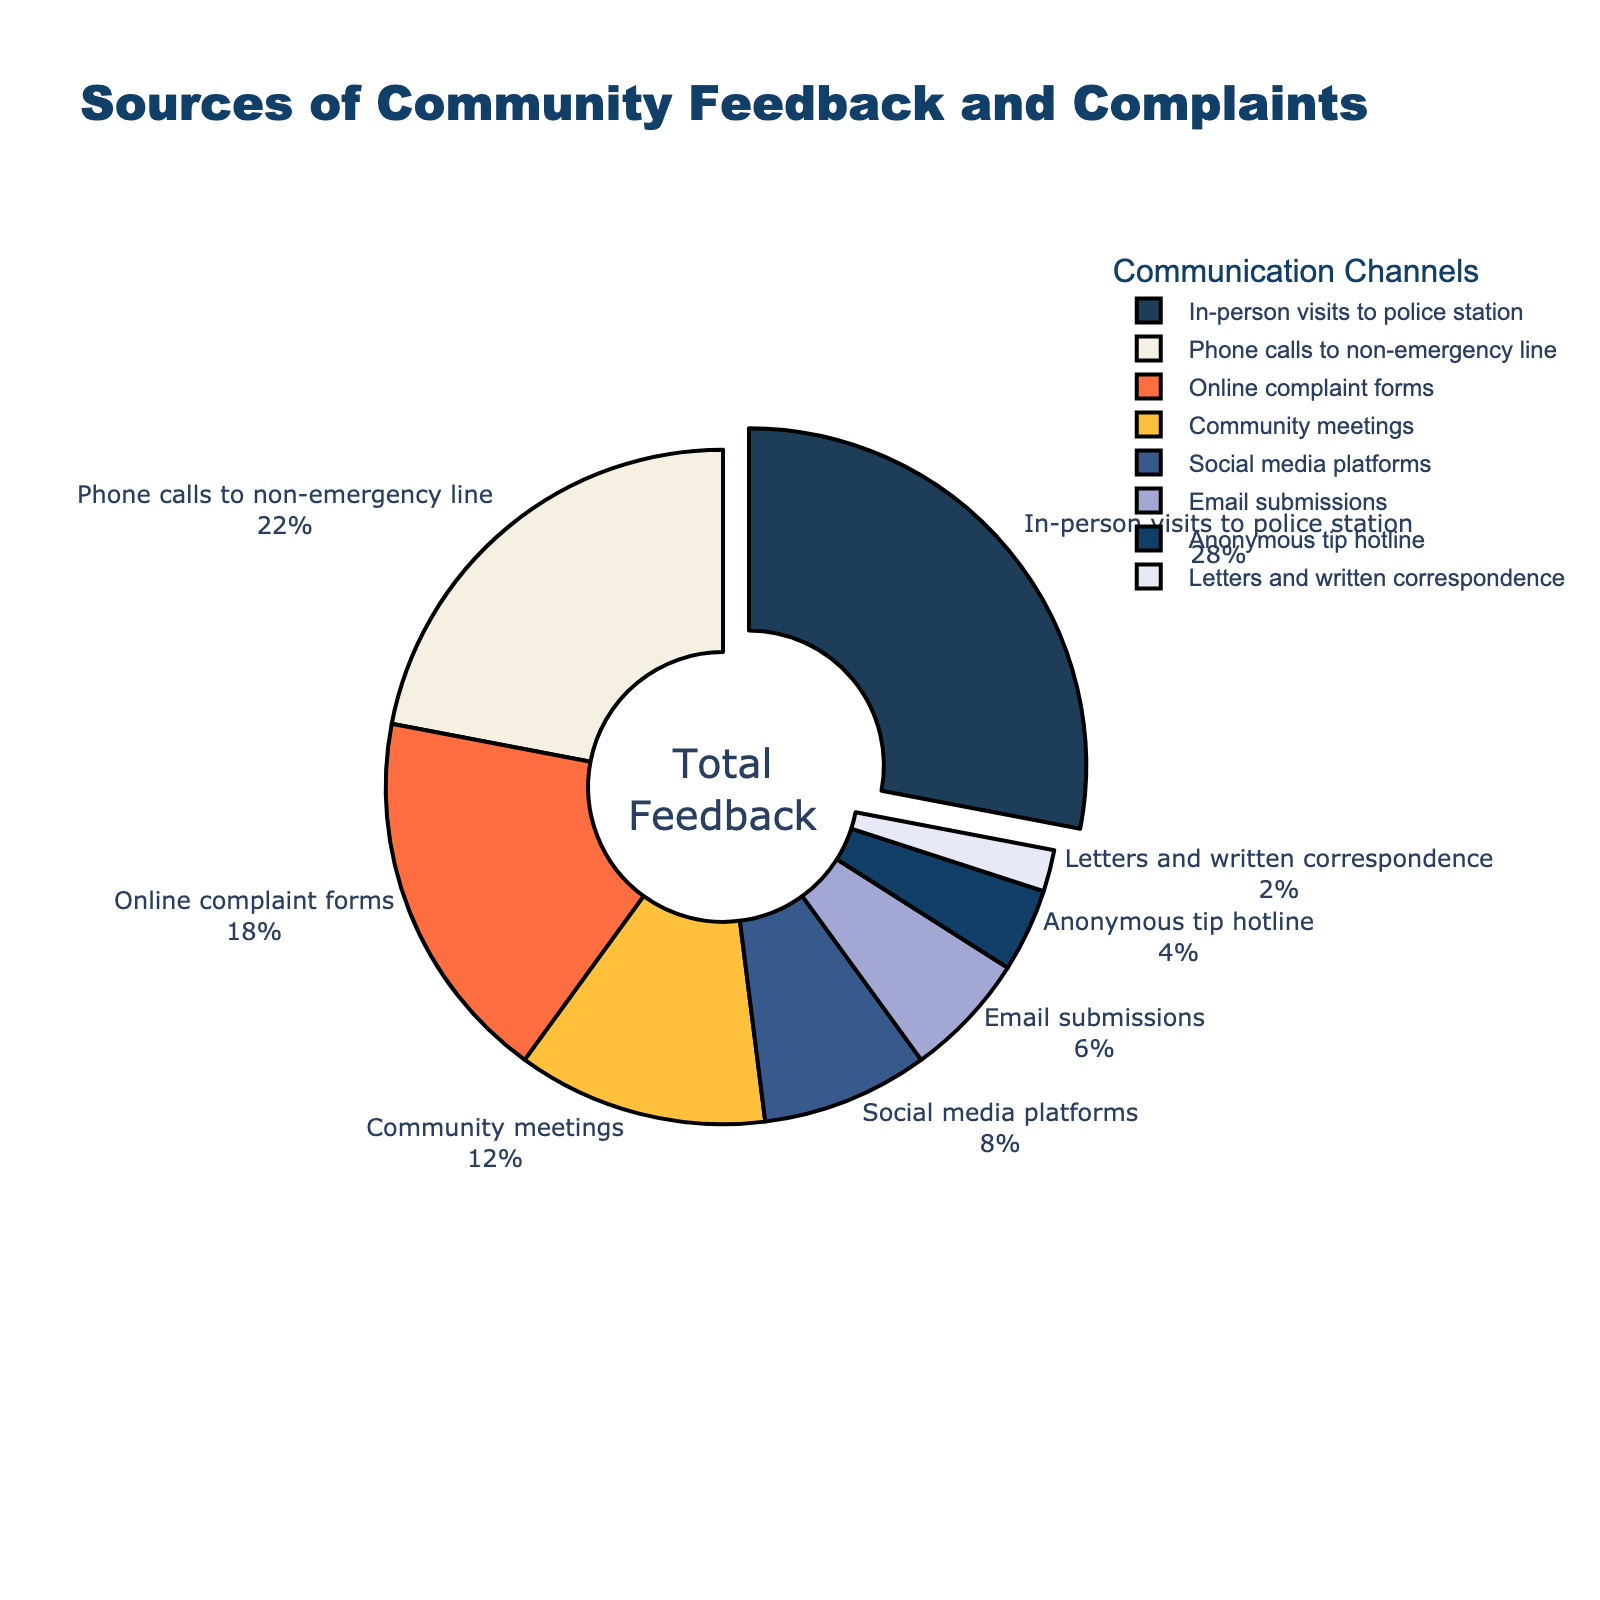In which communication channel did the police department receive the highest percentage of feedback? By observing the donut chart, the sector that is slightly pulled out indicates the communication channel with the highest percentage. This sector represents "In-person visits to police station" with 28%.
Answer: In-person visits to police station Which channels combined account for more than half of the feedback? To find this, consider the channels one by one from the highest to the lowest percentages until the combined total exceeds 50%. "In-person visits to police station" (28%) + "Phone calls to non-emergency line" (22%) = 50%, which is exactly half. Adding "Online complaint forms" (18%) exceeds half.
Answer: In-person visits to police station, Phone calls to non-emergency line, Online complaint forms What is the percentage difference between the most and least used communication channels? The most used channel is "In-person visits to police station" with 28%, and the least used is "Letters and written correspondence" with 2%. Subtract the least from the most: 28% - 2% = 26%.
Answer: 26% How much more feedback is received from "Community meetings" compared to "Social media platforms"? "Community meetings" account for 12%, while "Social media platforms" account for 8%. Subtract the smaller percentage from the larger one: 12% - 8% = 4%.
Answer: 4% Summing all the channels with less than 10% feedback, what is their total contribution? Add the percentages of channels with less than 10%: "Social media platforms" (8%) + "Email submissions" (6%) + "Anonymous tip hotline" (4%) + "Letters and written correspondence" (2%) = 8% + 6% + 4% + 2% = 20%.
Answer: 20% Which communication channels combined make up exactly 40% of the feedback? By checking different combinations that total 40%, one valid combination is "Phone calls to non-emergency line" (22%) and "Online complaint forms" (18%).
Answer: Phone calls to non-emergency line, Online complaint forms What's the average percentage of feedback received through all listed communication channels? To find the average, sum all percentages and divide by the number of channels: (28 + 22 + 18 + 12 + 8 + 6 + 4 + 2) / 8 = 100 / 8 = 12.5%.
Answer: 12.5% Which color represents the "Email submissions" section in the chart? By examining the color coding of the segments in the donut chart, the "Email submissions" section is represented by a shade of light blue-purple.
Answer: Light blue-purple ([[mention the exact color if it has a specific name]]) Is the feedback received through "Online complaint forms" greater than the combined feedback from "Social media platforms" and "Email submissions"? "Online complaint forms" account for 18%. "Social media platforms" and "Email submissions" combined are 8% + 6% = 14%. Since 18% > 14%, the answer is yes.
Answer: Yes 